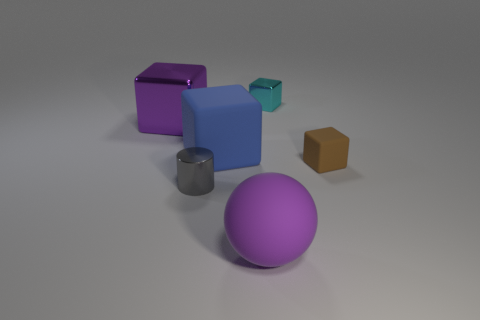Subtract all small metal cubes. How many cubes are left? 3 Add 3 small gray shiny things. How many objects exist? 9 Subtract all brown cubes. How many cubes are left? 3 Subtract all cylinders. How many objects are left? 5 Subtract all green blocks. Subtract all brown balls. How many blocks are left? 4 Subtract all small metallic balls. Subtract all blue rubber cubes. How many objects are left? 5 Add 2 tiny objects. How many tiny objects are left? 5 Add 1 large purple cubes. How many large purple cubes exist? 2 Subtract 0 cyan cylinders. How many objects are left? 6 